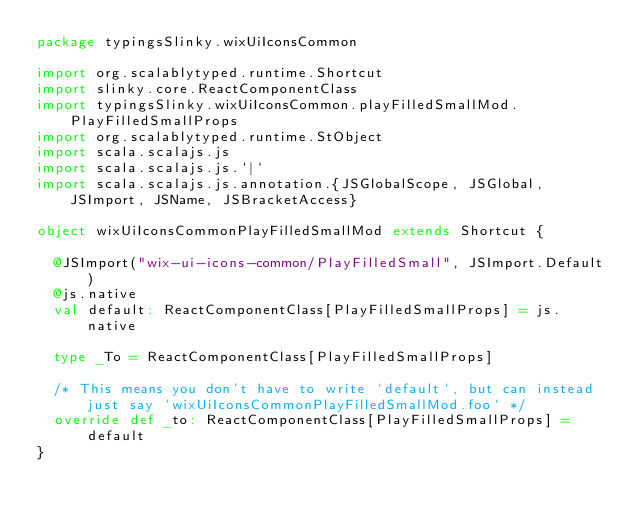<code> <loc_0><loc_0><loc_500><loc_500><_Scala_>package typingsSlinky.wixUiIconsCommon

import org.scalablytyped.runtime.Shortcut
import slinky.core.ReactComponentClass
import typingsSlinky.wixUiIconsCommon.playFilledSmallMod.PlayFilledSmallProps
import org.scalablytyped.runtime.StObject
import scala.scalajs.js
import scala.scalajs.js.`|`
import scala.scalajs.js.annotation.{JSGlobalScope, JSGlobal, JSImport, JSName, JSBracketAccess}

object wixUiIconsCommonPlayFilledSmallMod extends Shortcut {
  
  @JSImport("wix-ui-icons-common/PlayFilledSmall", JSImport.Default)
  @js.native
  val default: ReactComponentClass[PlayFilledSmallProps] = js.native
  
  type _To = ReactComponentClass[PlayFilledSmallProps]
  
  /* This means you don't have to write `default`, but can instead just say `wixUiIconsCommonPlayFilledSmallMod.foo` */
  override def _to: ReactComponentClass[PlayFilledSmallProps] = default
}
</code> 